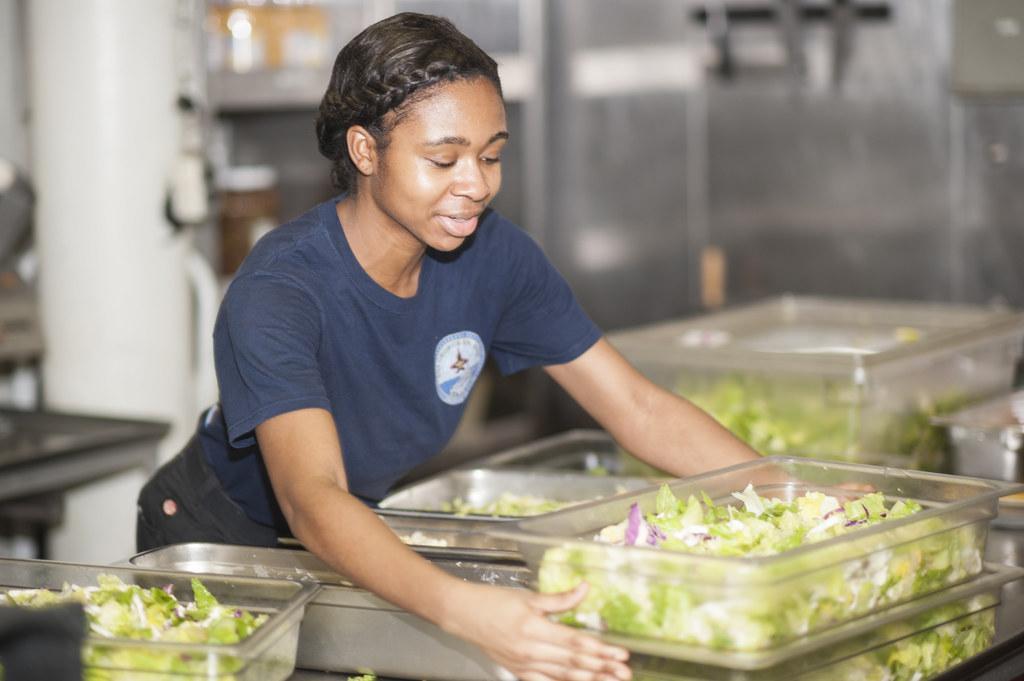Could you give a brief overview of what you see in this image? In the center of the image there is a woman standing at the table. On the table there are containers and vegetables. In the background there is a wall and equipment. 